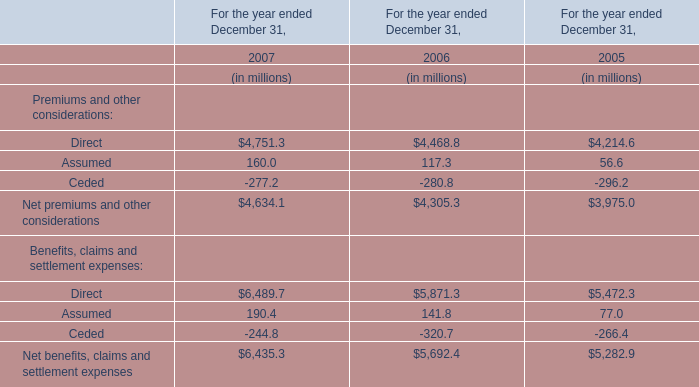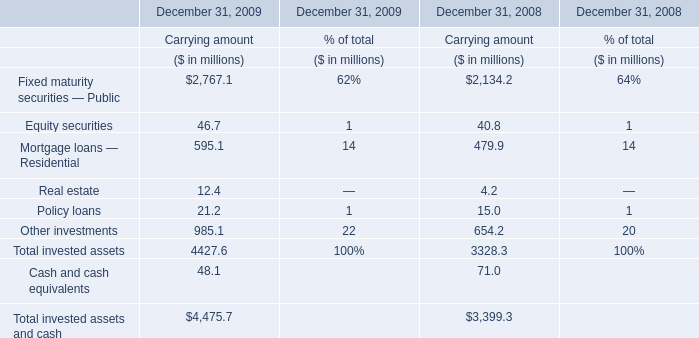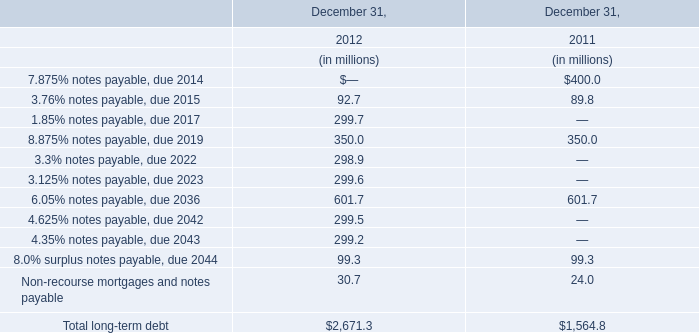What is the sum of 3.3% notes payable, due 2022 in 2012 and Net premiums and other considerations in 2006? (in million) 
Computations: (298.9 + 4305.3)
Answer: 4604.2. 